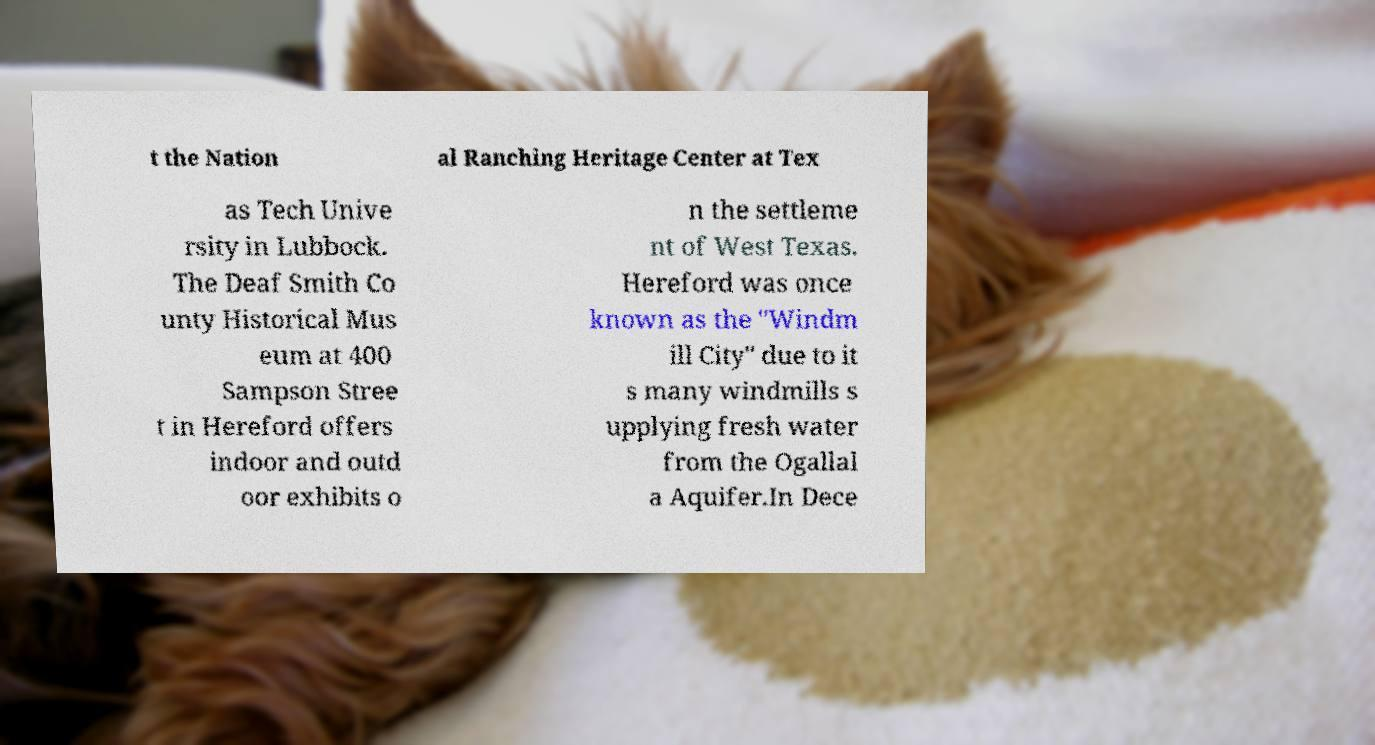Could you extract and type out the text from this image? t the Nation al Ranching Heritage Center at Tex as Tech Unive rsity in Lubbock. The Deaf Smith Co unty Historical Mus eum at 400 Sampson Stree t in Hereford offers indoor and outd oor exhibits o n the settleme nt of West Texas. Hereford was once known as the "Windm ill City" due to it s many windmills s upplying fresh water from the Ogallal a Aquifer.In Dece 